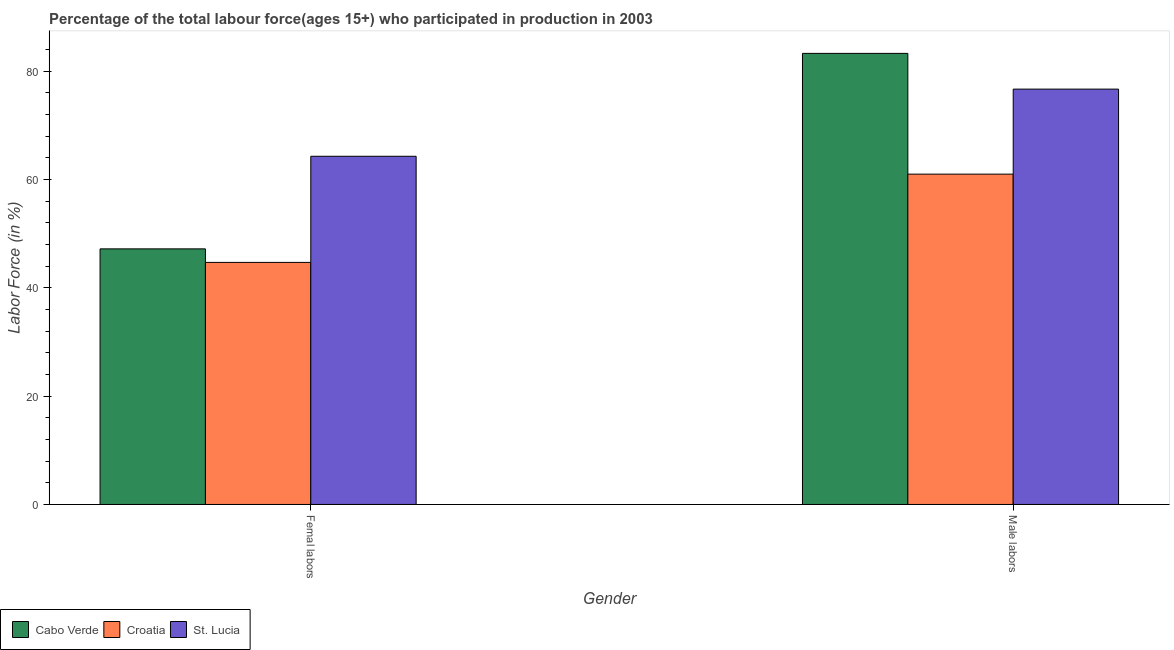How many different coloured bars are there?
Make the answer very short. 3. Are the number of bars per tick equal to the number of legend labels?
Offer a very short reply. Yes. What is the label of the 2nd group of bars from the left?
Keep it short and to the point. Male labors. What is the percentage of male labour force in Croatia?
Provide a short and direct response. 61. Across all countries, what is the maximum percentage of female labor force?
Offer a terse response. 64.3. Across all countries, what is the minimum percentage of male labour force?
Keep it short and to the point. 61. In which country was the percentage of female labor force maximum?
Provide a succinct answer. St. Lucia. In which country was the percentage of male labour force minimum?
Make the answer very short. Croatia. What is the total percentage of male labour force in the graph?
Keep it short and to the point. 221. What is the difference between the percentage of male labour force in St. Lucia and that in Cabo Verde?
Keep it short and to the point. -6.6. What is the difference between the percentage of female labor force in Croatia and the percentage of male labour force in Cabo Verde?
Your response must be concise. -38.6. What is the average percentage of female labor force per country?
Keep it short and to the point. 52.07. What is the difference between the percentage of male labour force and percentage of female labor force in Croatia?
Provide a succinct answer. 16.3. In how many countries, is the percentage of female labor force greater than 24 %?
Make the answer very short. 3. What is the ratio of the percentage of female labor force in St. Lucia to that in Cabo Verde?
Keep it short and to the point. 1.36. Is the percentage of female labor force in Cabo Verde less than that in Croatia?
Provide a succinct answer. No. In how many countries, is the percentage of female labor force greater than the average percentage of female labor force taken over all countries?
Your answer should be compact. 1. What does the 3rd bar from the left in Femal labors represents?
Offer a very short reply. St. Lucia. What does the 2nd bar from the right in Male labors represents?
Offer a terse response. Croatia. What is the difference between two consecutive major ticks on the Y-axis?
Ensure brevity in your answer.  20. Where does the legend appear in the graph?
Provide a short and direct response. Bottom left. How many legend labels are there?
Ensure brevity in your answer.  3. How are the legend labels stacked?
Make the answer very short. Horizontal. What is the title of the graph?
Your response must be concise. Percentage of the total labour force(ages 15+) who participated in production in 2003. Does "Low & middle income" appear as one of the legend labels in the graph?
Offer a very short reply. No. What is the label or title of the Y-axis?
Make the answer very short. Labor Force (in %). What is the Labor Force (in %) in Cabo Verde in Femal labors?
Make the answer very short. 47.2. What is the Labor Force (in %) of Croatia in Femal labors?
Make the answer very short. 44.7. What is the Labor Force (in %) of St. Lucia in Femal labors?
Give a very brief answer. 64.3. What is the Labor Force (in %) of Cabo Verde in Male labors?
Make the answer very short. 83.3. What is the Labor Force (in %) of St. Lucia in Male labors?
Keep it short and to the point. 76.7. Across all Gender, what is the maximum Labor Force (in %) in Cabo Verde?
Your response must be concise. 83.3. Across all Gender, what is the maximum Labor Force (in %) in St. Lucia?
Offer a terse response. 76.7. Across all Gender, what is the minimum Labor Force (in %) of Cabo Verde?
Your answer should be compact. 47.2. Across all Gender, what is the minimum Labor Force (in %) in Croatia?
Offer a terse response. 44.7. Across all Gender, what is the minimum Labor Force (in %) in St. Lucia?
Your response must be concise. 64.3. What is the total Labor Force (in %) of Cabo Verde in the graph?
Keep it short and to the point. 130.5. What is the total Labor Force (in %) of Croatia in the graph?
Offer a terse response. 105.7. What is the total Labor Force (in %) of St. Lucia in the graph?
Keep it short and to the point. 141. What is the difference between the Labor Force (in %) in Cabo Verde in Femal labors and that in Male labors?
Provide a succinct answer. -36.1. What is the difference between the Labor Force (in %) in Croatia in Femal labors and that in Male labors?
Your answer should be very brief. -16.3. What is the difference between the Labor Force (in %) in Cabo Verde in Femal labors and the Labor Force (in %) in St. Lucia in Male labors?
Keep it short and to the point. -29.5. What is the difference between the Labor Force (in %) in Croatia in Femal labors and the Labor Force (in %) in St. Lucia in Male labors?
Your answer should be very brief. -32. What is the average Labor Force (in %) of Cabo Verde per Gender?
Your answer should be compact. 65.25. What is the average Labor Force (in %) in Croatia per Gender?
Offer a very short reply. 52.85. What is the average Labor Force (in %) of St. Lucia per Gender?
Give a very brief answer. 70.5. What is the difference between the Labor Force (in %) of Cabo Verde and Labor Force (in %) of St. Lucia in Femal labors?
Your answer should be very brief. -17.1. What is the difference between the Labor Force (in %) of Croatia and Labor Force (in %) of St. Lucia in Femal labors?
Offer a terse response. -19.6. What is the difference between the Labor Force (in %) in Cabo Verde and Labor Force (in %) in Croatia in Male labors?
Provide a succinct answer. 22.3. What is the difference between the Labor Force (in %) in Croatia and Labor Force (in %) in St. Lucia in Male labors?
Ensure brevity in your answer.  -15.7. What is the ratio of the Labor Force (in %) in Cabo Verde in Femal labors to that in Male labors?
Keep it short and to the point. 0.57. What is the ratio of the Labor Force (in %) of Croatia in Femal labors to that in Male labors?
Make the answer very short. 0.73. What is the ratio of the Labor Force (in %) in St. Lucia in Femal labors to that in Male labors?
Ensure brevity in your answer.  0.84. What is the difference between the highest and the second highest Labor Force (in %) in Cabo Verde?
Offer a very short reply. 36.1. What is the difference between the highest and the second highest Labor Force (in %) in Croatia?
Ensure brevity in your answer.  16.3. What is the difference between the highest and the second highest Labor Force (in %) in St. Lucia?
Give a very brief answer. 12.4. What is the difference between the highest and the lowest Labor Force (in %) in Cabo Verde?
Your response must be concise. 36.1. 